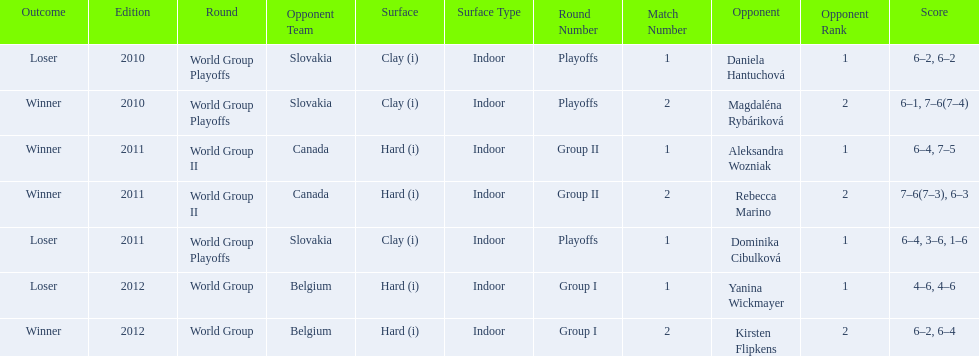What was the next game listed after the world group ii rounds? World Group Playoffs. 